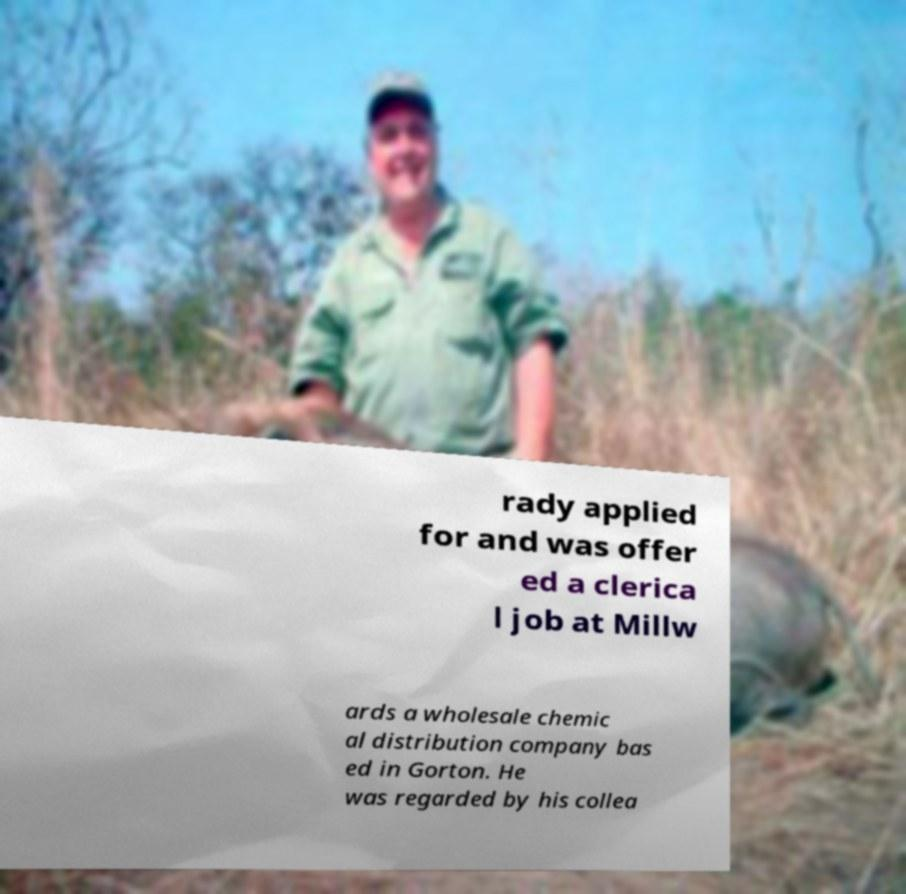Could you extract and type out the text from this image? rady applied for and was offer ed a clerica l job at Millw ards a wholesale chemic al distribution company bas ed in Gorton. He was regarded by his collea 